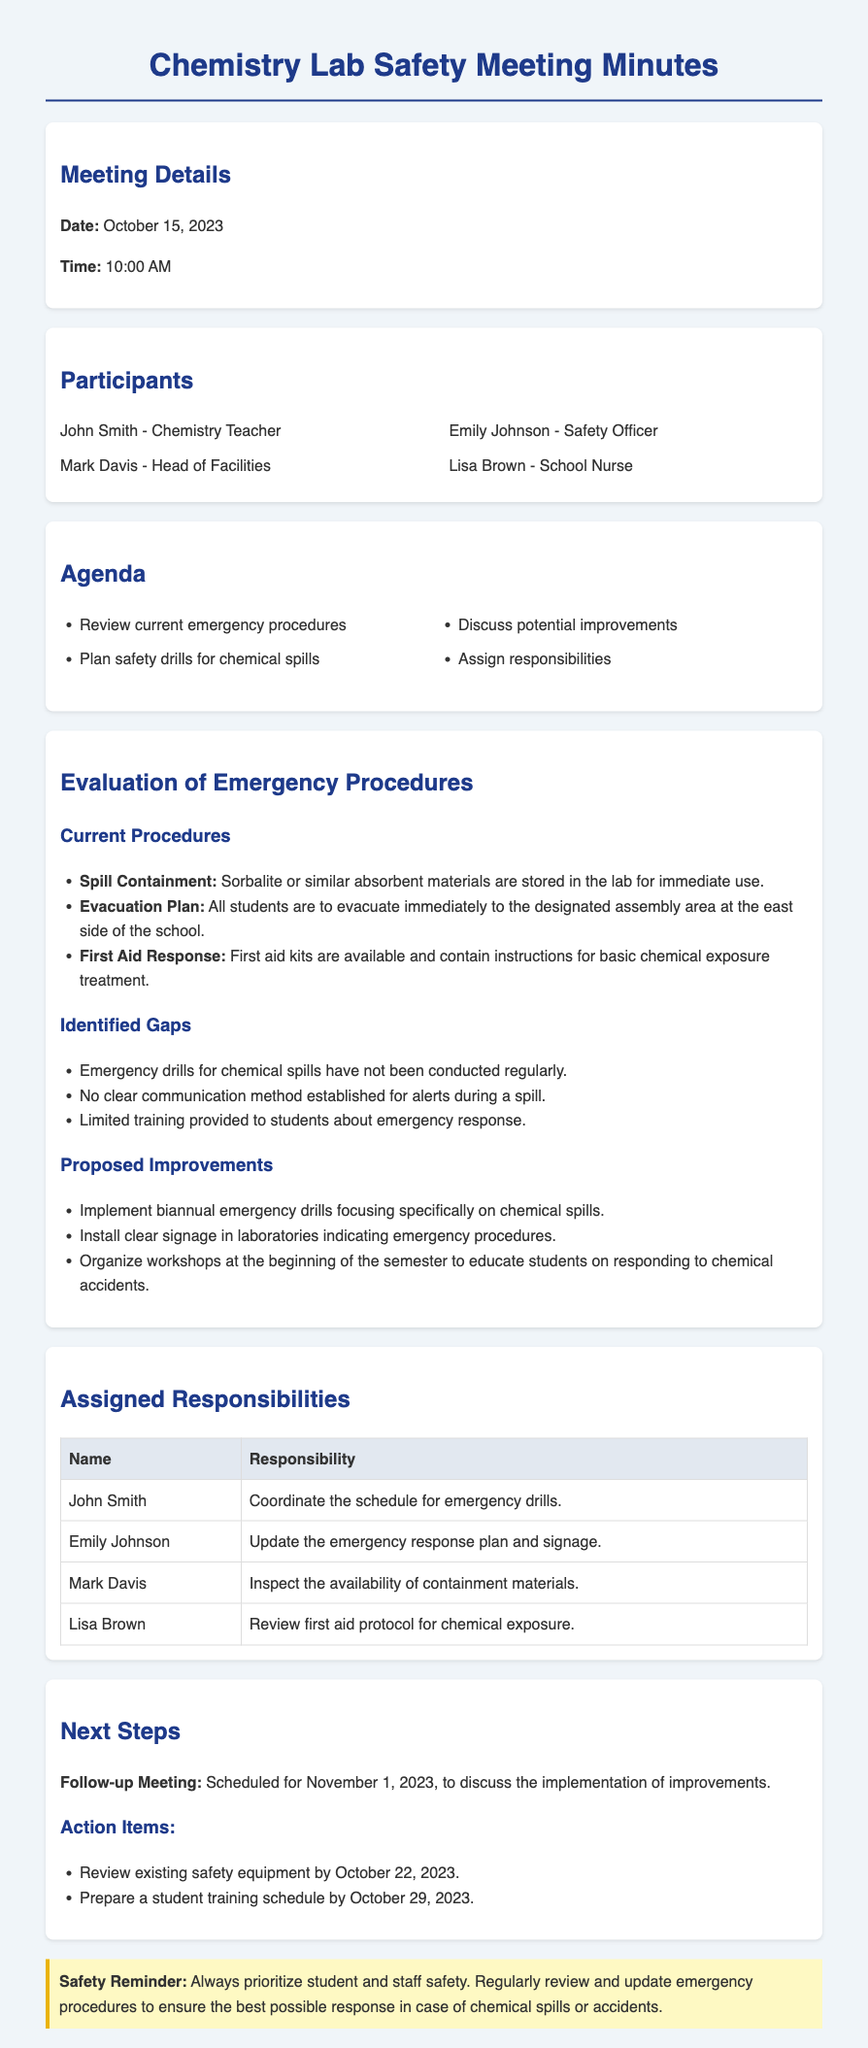what is the date of the meeting? The date of the meeting is explicitly stated in the meeting details section.
Answer: October 15, 2023 who is the safety officer present at the meeting? The safety officer's name is listed among the participants.
Answer: Emily Johnson what is one identified gap in the current emergency procedures? The document lists several gaps in the evaluation section, calling attention to specifics about emergency drills.
Answer: Emergency drills for chemical spills have not been conducted regularly how often should emergency drills be implemented according to proposed improvements? The proposed improvements specify a frequency for the drills.
Answer: biannual who is responsible for coordinating the schedule for emergency drills? The responsibilities assigned indicate who holds the coordination role.
Answer: John Smith what is a proposed action item due by October 22, 2023? The action items section outlines specific tasks with due dates.
Answer: Review existing safety equipment which area of the school should students evacuate to during an emergency? The evacuation plan clearly states the designated area for assembly.
Answer: east side of the school which two participants are assigned to update the emergency response plan and review first aid protocol? The table of assigned responsibilities highlights both of these roles.
Answer: Emily Johnson and Lisa Brown what is the time of the follow-up meeting? The follow-up meeting details include the specific time for the next discussion.
Answer: 10:00 AM 